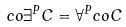Convert formula to latex. <formula><loc_0><loc_0><loc_500><loc_500>c o \exists ^ { P } C = \forall ^ { P } c o C</formula> 